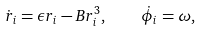<formula> <loc_0><loc_0><loc_500><loc_500>\dot { r } _ { i } = \epsilon r _ { i } - B r _ { i } ^ { 3 } , \quad \dot { \phi } _ { i } = \omega ,</formula> 